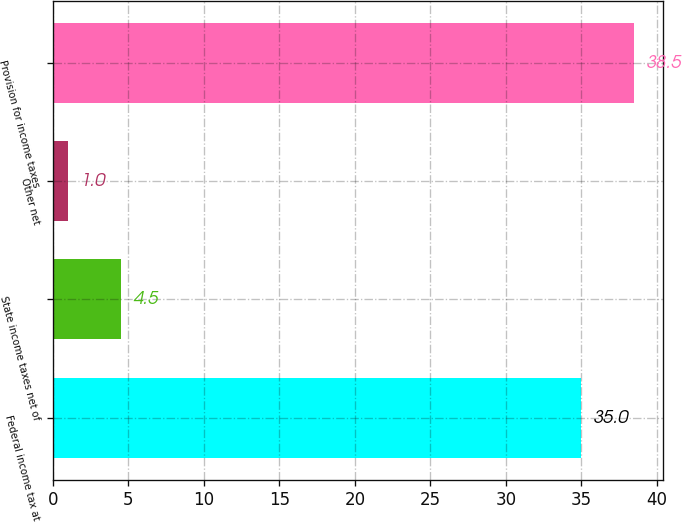Convert chart to OTSL. <chart><loc_0><loc_0><loc_500><loc_500><bar_chart><fcel>Federal income tax at<fcel>State income taxes net of<fcel>Other net<fcel>Provision for income taxes<nl><fcel>35<fcel>4.5<fcel>1<fcel>38.5<nl></chart> 